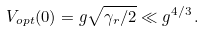Convert formula to latex. <formula><loc_0><loc_0><loc_500><loc_500>V _ { o p t } ( 0 ) = g \sqrt { \gamma _ { r } / 2 } \ll g ^ { 4 / 3 } \, .</formula> 